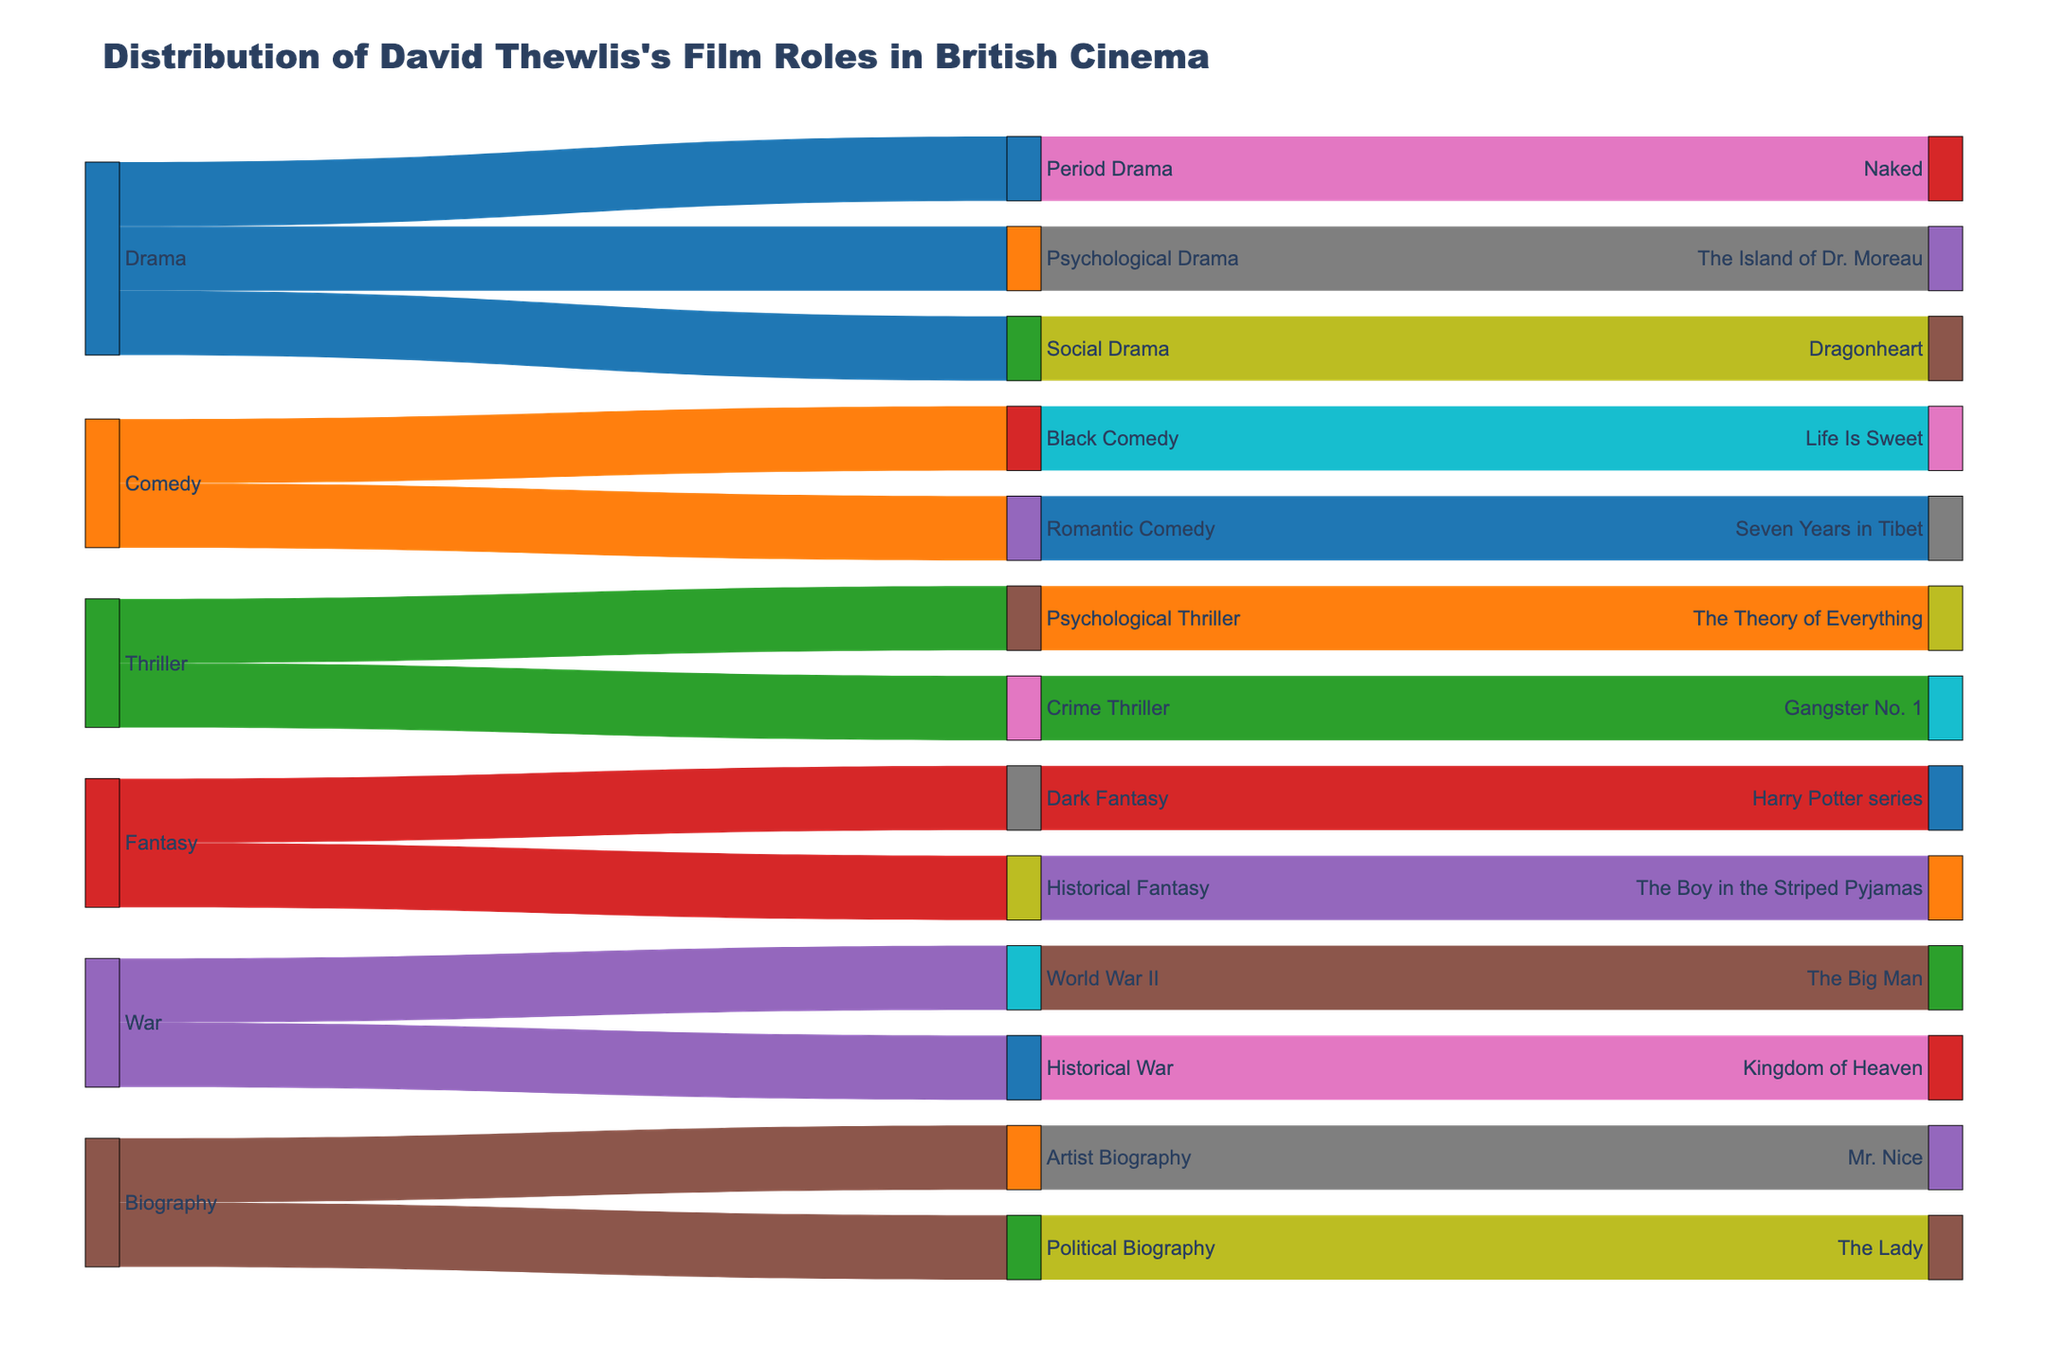How many films did David Thewlis have roles in within the drama genre? Count the number of films under the subgenres "Period Drama," "Psychological Drama," and "Social Drama." There are three films listed: "Naked," "The Island of Dr. Moreau," and "Dragonheart."
Answer: 3 Which genre has the most subgenres listed in the Sankey diagram? Count the subgenres for each genre: Drama (3), Comedy (2), Thriller (2), Fantasy (2), War (2), Biography (2). Drama has the most subgenres.
Answer: Drama Are there more fantasy or war films listed in the diagram? Count the films under each genre. Fantasy includes "Harry Potter series" and "The Boy in the Striped Pyjamas," whereas War includes "The Big Man" and "Kingdom of Heaven." Both genres have two films each.
Answer: Equal Which subgenre has the highest number of films listed? Identify the subgenres with their corresponding films: Period Drama (1), Psychological Drama (1), Social Drama (1), Black Comedy (1), Romantic Comedy (1), Psychological Thriller (1), Crime Thriller (1), Dark Fantasy (1), Historical Fantasy (1), World War II (1), Historical War (1), Artist Biography (1), Political Biography (1). Each subgenre has one film.
Answer: All subgenres have one film How many genres are represented in the Sankey diagram? Count the unique genres: Drama, Comedy, Thriller, Fantasy, War, Biography. There are six genres.
Answer: 6 What is the most common color used for the genres in the diagram? Observe the color scale and the number of genres represented. Most genres are depicted in distinct colors, making it difficult to determine a single most common color among the genres.
Answer: Various colors Does David Thewlis have more roles in films classified under biography or thriller genres? Count the films under each genre: Biography includes "Mr. Nice" and "The Lady," while Thriller includes "The Theory of Everything" and "Gangster No. 1." Both genres have two films.
Answer: Equal What proportion of the total films does the fantasy genre represent? There are 13 films in total and 2 belong to the fantasy genre (2/13). To find the proportion, 2 divided by 13 equals approximately 0.1538, which is about 15.38%.
Answer: 15.38% Which specific film is listed under the subgenre 'World War II'? Identify the film connected to 'World War II' in the diagram. It is "The Big Man."
Answer: The Big Man Are there any films that fall under more than one subgenre in the diagram? Analyze each film under their subgenres. Each film is listed under a distinct subgenre, meaning no film is categorized under more than one subgenre.
Answer: No 